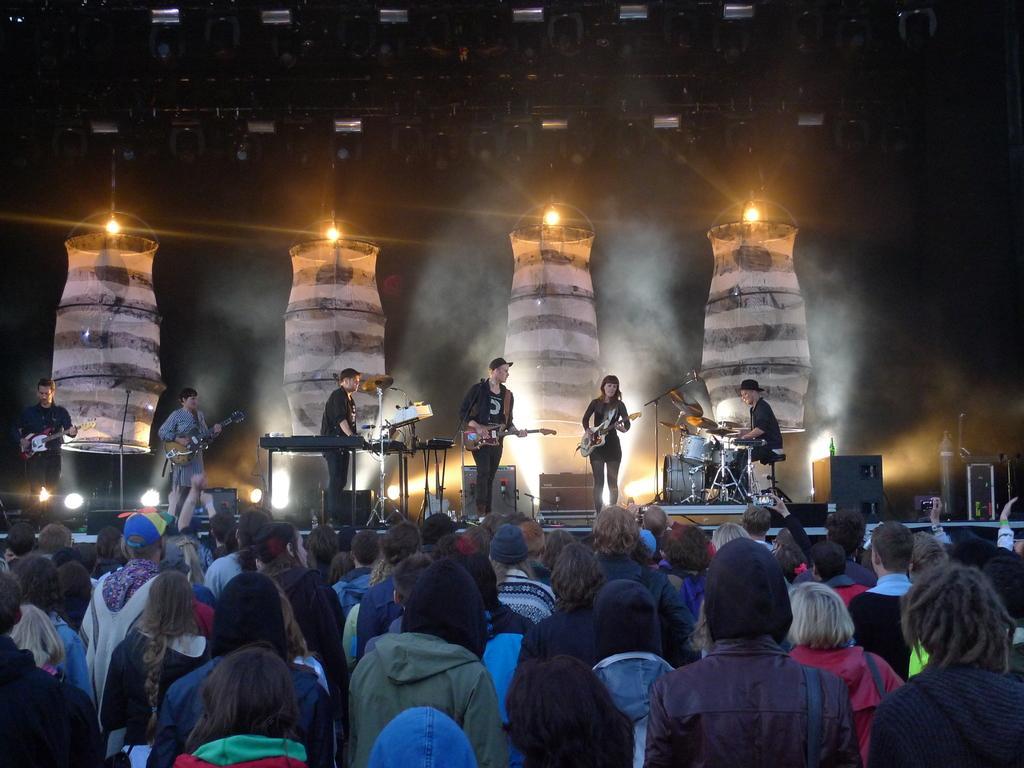Please provide a concise description of this image. In the foreground I can see a crowd on the road and a group of people are playing musical instruments on the stage, speakers, mikes and so on. In the background I can see lighting lamps, metal rods, focus lights and smoke. This image is taken may be during night. 